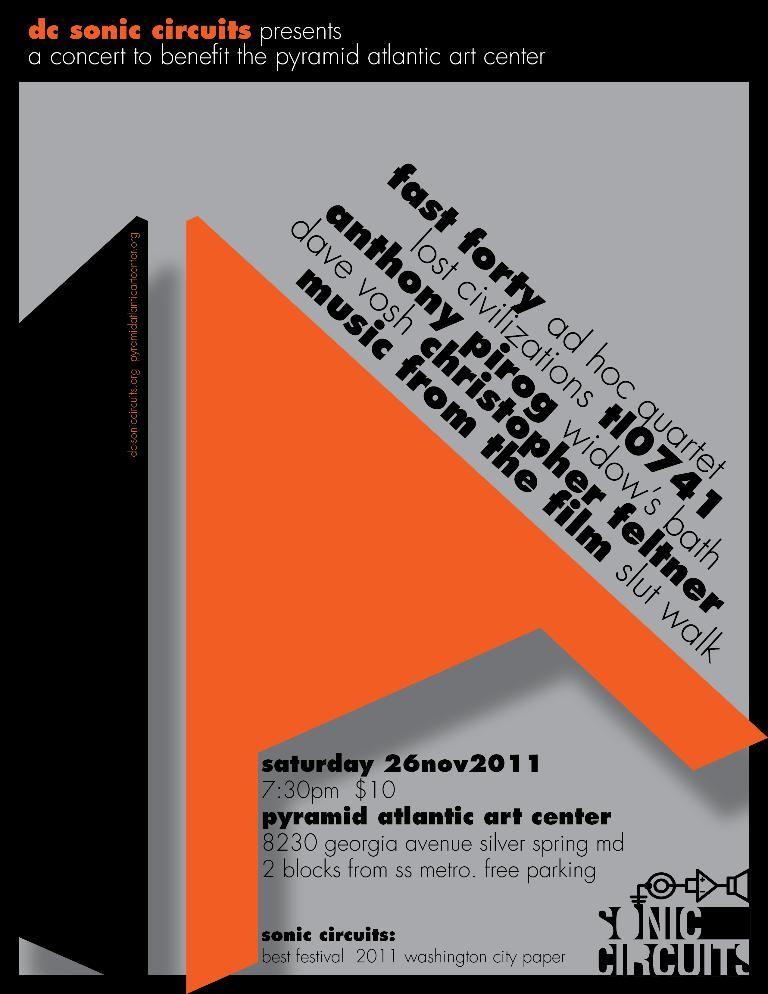<image>
Present a compact description of the photo's key features. Poster for an event that takes place on November 26th. 